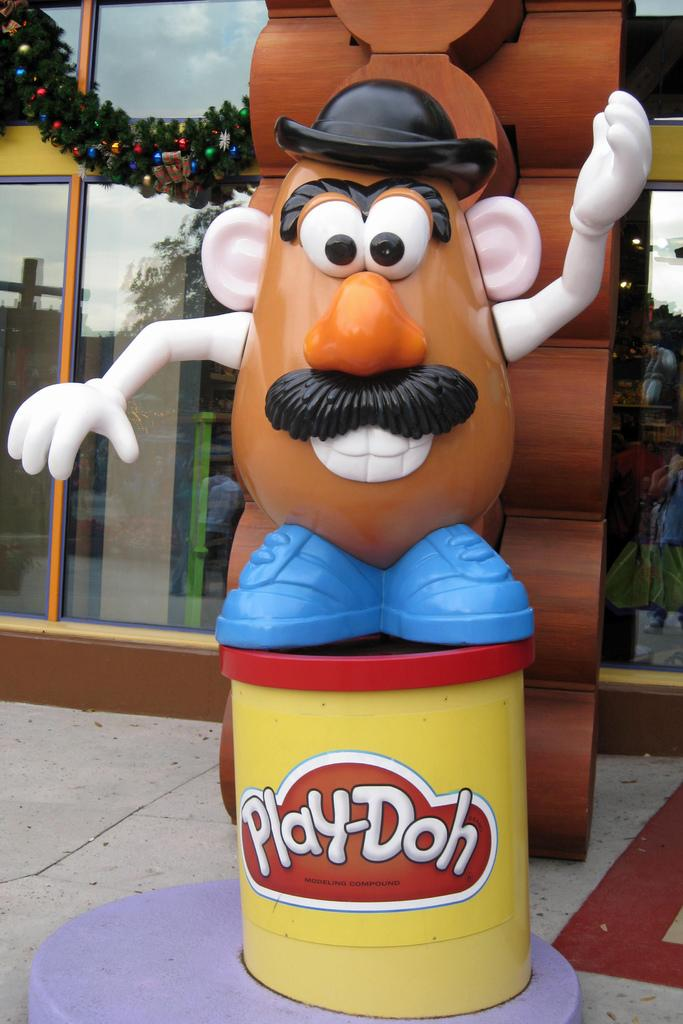What activity is the group of people engaged in in the image? The group of people is playing soccer. What object is essential for playing soccer that is visible in the image? There is a soccer ball in the image. What type of drink is being passed around among the soccer players in the image? There is no drink visible in the image; the focus is on the group of people playing soccer and the soccer ball. 